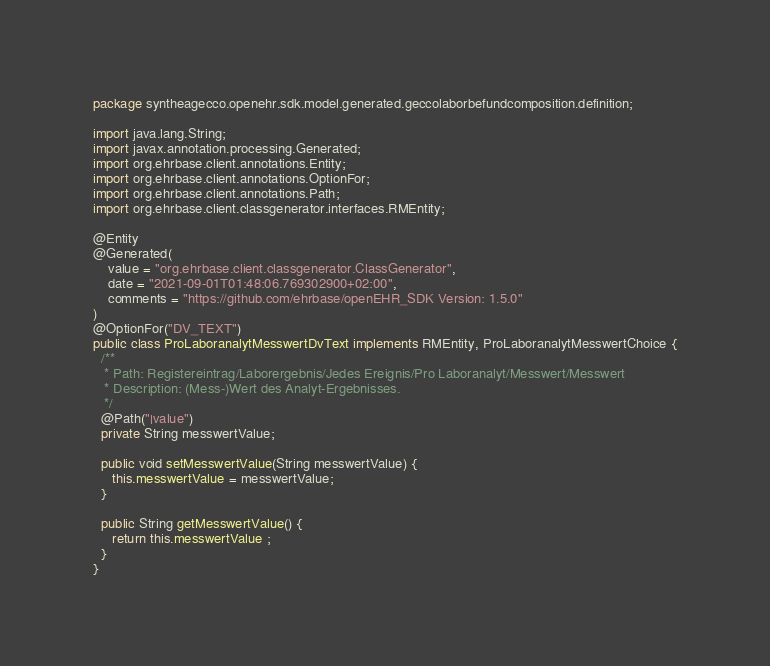<code> <loc_0><loc_0><loc_500><loc_500><_Java_>package syntheagecco.openehr.sdk.model.generated.geccolaborbefundcomposition.definition;

import java.lang.String;
import javax.annotation.processing.Generated;
import org.ehrbase.client.annotations.Entity;
import org.ehrbase.client.annotations.OptionFor;
import org.ehrbase.client.annotations.Path;
import org.ehrbase.client.classgenerator.interfaces.RMEntity;

@Entity
@Generated(
    value = "org.ehrbase.client.classgenerator.ClassGenerator",
    date = "2021-09-01T01:48:06.769302900+02:00",
    comments = "https://github.com/ehrbase/openEHR_SDK Version: 1.5.0"
)
@OptionFor("DV_TEXT")
public class ProLaboranalytMesswertDvText implements RMEntity, ProLaboranalytMesswertChoice {
  /**
   * Path: Registereintrag/Laborergebnis/Jedes Ereignis/Pro Laboranalyt/Messwert/Messwert
   * Description: (Mess-)Wert des Analyt-Ergebnisses.
   */
  @Path("|value")
  private String messwertValue;

  public void setMesswertValue(String messwertValue) {
     this.messwertValue = messwertValue;
  }

  public String getMesswertValue() {
     return this.messwertValue ;
  }
}
</code> 